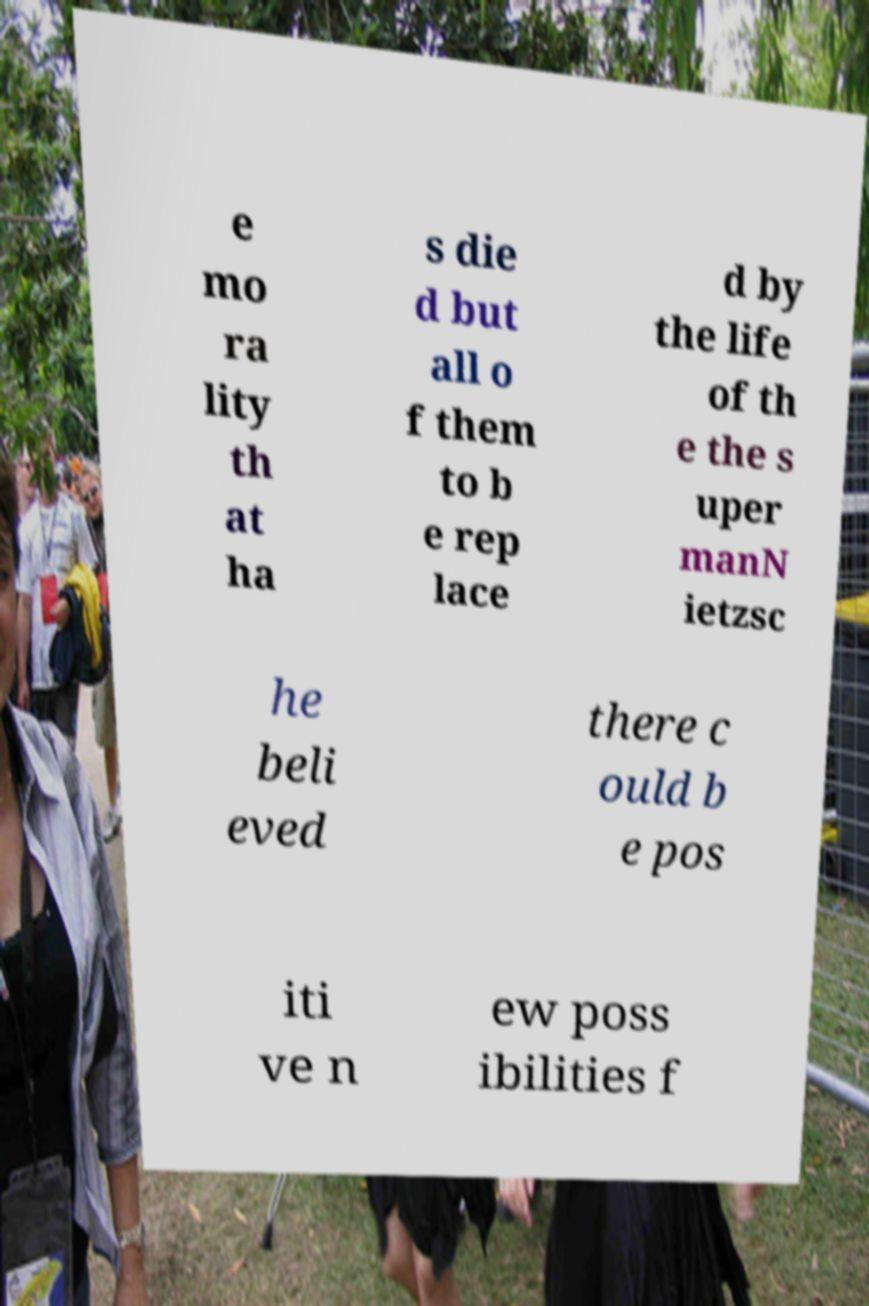Could you extract and type out the text from this image? e mo ra lity th at ha s die d but all o f them to b e rep lace d by the life of th e the s uper manN ietzsc he beli eved there c ould b e pos iti ve n ew poss ibilities f 